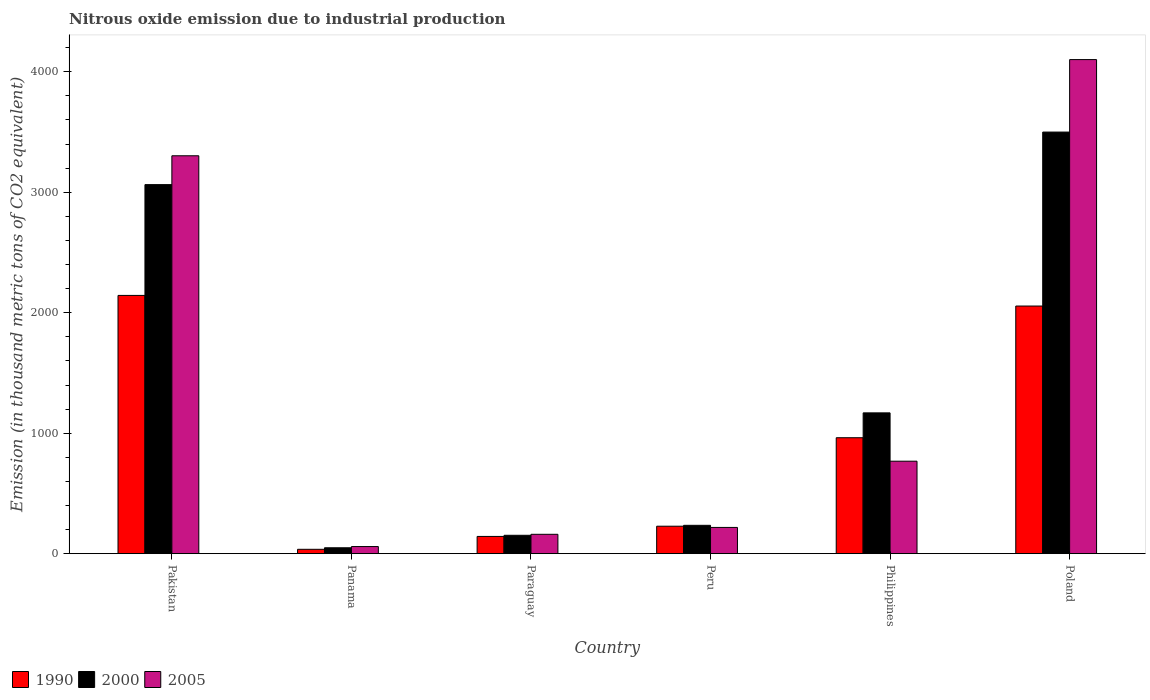How many different coloured bars are there?
Offer a terse response. 3. How many groups of bars are there?
Offer a very short reply. 6. Are the number of bars per tick equal to the number of legend labels?
Your answer should be compact. Yes. How many bars are there on the 6th tick from the left?
Your answer should be very brief. 3. How many bars are there on the 4th tick from the right?
Ensure brevity in your answer.  3. In how many cases, is the number of bars for a given country not equal to the number of legend labels?
Provide a short and direct response. 0. Across all countries, what is the maximum amount of nitrous oxide emitted in 2000?
Offer a terse response. 3499.7. Across all countries, what is the minimum amount of nitrous oxide emitted in 1990?
Provide a succinct answer. 36.2. In which country was the amount of nitrous oxide emitted in 1990 maximum?
Ensure brevity in your answer.  Pakistan. In which country was the amount of nitrous oxide emitted in 2000 minimum?
Ensure brevity in your answer.  Panama. What is the total amount of nitrous oxide emitted in 2000 in the graph?
Provide a short and direct response. 8168.4. What is the difference between the amount of nitrous oxide emitted in 2005 in Panama and that in Poland?
Your answer should be compact. -4042.5. What is the difference between the amount of nitrous oxide emitted in 2000 in Philippines and the amount of nitrous oxide emitted in 2005 in Paraguay?
Your answer should be very brief. 1008.1. What is the average amount of nitrous oxide emitted in 2000 per country?
Ensure brevity in your answer.  1361.4. What is the difference between the amount of nitrous oxide emitted of/in 2005 and amount of nitrous oxide emitted of/in 2000 in Poland?
Offer a very short reply. 601.8. What is the ratio of the amount of nitrous oxide emitted in 1990 in Pakistan to that in Paraguay?
Your answer should be compact. 14.99. Is the amount of nitrous oxide emitted in 1990 in Pakistan less than that in Philippines?
Give a very brief answer. No. Is the difference between the amount of nitrous oxide emitted in 2005 in Panama and Paraguay greater than the difference between the amount of nitrous oxide emitted in 2000 in Panama and Paraguay?
Offer a very short reply. Yes. What is the difference between the highest and the second highest amount of nitrous oxide emitted in 2005?
Provide a succinct answer. 798.6. What is the difference between the highest and the lowest amount of nitrous oxide emitted in 1990?
Provide a succinct answer. 2107.6. In how many countries, is the amount of nitrous oxide emitted in 2005 greater than the average amount of nitrous oxide emitted in 2005 taken over all countries?
Provide a short and direct response. 2. Is the sum of the amount of nitrous oxide emitted in 2005 in Peru and Philippines greater than the maximum amount of nitrous oxide emitted in 2000 across all countries?
Provide a short and direct response. No. What does the 3rd bar from the left in Philippines represents?
Your answer should be compact. 2005. Is it the case that in every country, the sum of the amount of nitrous oxide emitted in 2000 and amount of nitrous oxide emitted in 1990 is greater than the amount of nitrous oxide emitted in 2005?
Provide a short and direct response. Yes. How many bars are there?
Ensure brevity in your answer.  18. How many countries are there in the graph?
Make the answer very short. 6. What is the difference between two consecutive major ticks on the Y-axis?
Your answer should be compact. 1000. Where does the legend appear in the graph?
Your response must be concise. Bottom left. How are the legend labels stacked?
Give a very brief answer. Horizontal. What is the title of the graph?
Ensure brevity in your answer.  Nitrous oxide emission due to industrial production. What is the label or title of the X-axis?
Offer a terse response. Country. What is the label or title of the Y-axis?
Offer a very short reply. Emission (in thousand metric tons of CO2 equivalent). What is the Emission (in thousand metric tons of CO2 equivalent) in 1990 in Pakistan?
Provide a succinct answer. 2143.8. What is the Emission (in thousand metric tons of CO2 equivalent) of 2000 in Pakistan?
Your response must be concise. 3063.5. What is the Emission (in thousand metric tons of CO2 equivalent) in 2005 in Pakistan?
Your answer should be very brief. 3302.9. What is the Emission (in thousand metric tons of CO2 equivalent) of 1990 in Panama?
Provide a short and direct response. 36.2. What is the Emission (in thousand metric tons of CO2 equivalent) in 2000 in Panama?
Make the answer very short. 48.8. What is the Emission (in thousand metric tons of CO2 equivalent) in 2005 in Panama?
Your response must be concise. 59. What is the Emission (in thousand metric tons of CO2 equivalent) of 1990 in Paraguay?
Offer a very short reply. 143. What is the Emission (in thousand metric tons of CO2 equivalent) of 2000 in Paraguay?
Offer a terse response. 152.5. What is the Emission (in thousand metric tons of CO2 equivalent) in 2005 in Paraguay?
Offer a very short reply. 160.6. What is the Emission (in thousand metric tons of CO2 equivalent) in 1990 in Peru?
Keep it short and to the point. 227.9. What is the Emission (in thousand metric tons of CO2 equivalent) of 2000 in Peru?
Give a very brief answer. 235.2. What is the Emission (in thousand metric tons of CO2 equivalent) of 2005 in Peru?
Make the answer very short. 217.8. What is the Emission (in thousand metric tons of CO2 equivalent) of 1990 in Philippines?
Provide a short and direct response. 962.4. What is the Emission (in thousand metric tons of CO2 equivalent) in 2000 in Philippines?
Keep it short and to the point. 1168.7. What is the Emission (in thousand metric tons of CO2 equivalent) of 2005 in Philippines?
Keep it short and to the point. 767.6. What is the Emission (in thousand metric tons of CO2 equivalent) of 1990 in Poland?
Offer a terse response. 2055.6. What is the Emission (in thousand metric tons of CO2 equivalent) of 2000 in Poland?
Provide a short and direct response. 3499.7. What is the Emission (in thousand metric tons of CO2 equivalent) of 2005 in Poland?
Offer a terse response. 4101.5. Across all countries, what is the maximum Emission (in thousand metric tons of CO2 equivalent) of 1990?
Give a very brief answer. 2143.8. Across all countries, what is the maximum Emission (in thousand metric tons of CO2 equivalent) in 2000?
Ensure brevity in your answer.  3499.7. Across all countries, what is the maximum Emission (in thousand metric tons of CO2 equivalent) of 2005?
Offer a very short reply. 4101.5. Across all countries, what is the minimum Emission (in thousand metric tons of CO2 equivalent) of 1990?
Your response must be concise. 36.2. Across all countries, what is the minimum Emission (in thousand metric tons of CO2 equivalent) in 2000?
Offer a very short reply. 48.8. Across all countries, what is the minimum Emission (in thousand metric tons of CO2 equivalent) of 2005?
Offer a very short reply. 59. What is the total Emission (in thousand metric tons of CO2 equivalent) of 1990 in the graph?
Give a very brief answer. 5568.9. What is the total Emission (in thousand metric tons of CO2 equivalent) in 2000 in the graph?
Give a very brief answer. 8168.4. What is the total Emission (in thousand metric tons of CO2 equivalent) of 2005 in the graph?
Offer a terse response. 8609.4. What is the difference between the Emission (in thousand metric tons of CO2 equivalent) of 1990 in Pakistan and that in Panama?
Your answer should be compact. 2107.6. What is the difference between the Emission (in thousand metric tons of CO2 equivalent) of 2000 in Pakistan and that in Panama?
Offer a terse response. 3014.7. What is the difference between the Emission (in thousand metric tons of CO2 equivalent) in 2005 in Pakistan and that in Panama?
Your response must be concise. 3243.9. What is the difference between the Emission (in thousand metric tons of CO2 equivalent) in 1990 in Pakistan and that in Paraguay?
Your answer should be compact. 2000.8. What is the difference between the Emission (in thousand metric tons of CO2 equivalent) of 2000 in Pakistan and that in Paraguay?
Your answer should be compact. 2911. What is the difference between the Emission (in thousand metric tons of CO2 equivalent) of 2005 in Pakistan and that in Paraguay?
Provide a short and direct response. 3142.3. What is the difference between the Emission (in thousand metric tons of CO2 equivalent) of 1990 in Pakistan and that in Peru?
Your answer should be very brief. 1915.9. What is the difference between the Emission (in thousand metric tons of CO2 equivalent) in 2000 in Pakistan and that in Peru?
Provide a succinct answer. 2828.3. What is the difference between the Emission (in thousand metric tons of CO2 equivalent) of 2005 in Pakistan and that in Peru?
Your answer should be compact. 3085.1. What is the difference between the Emission (in thousand metric tons of CO2 equivalent) in 1990 in Pakistan and that in Philippines?
Offer a terse response. 1181.4. What is the difference between the Emission (in thousand metric tons of CO2 equivalent) of 2000 in Pakistan and that in Philippines?
Offer a very short reply. 1894.8. What is the difference between the Emission (in thousand metric tons of CO2 equivalent) in 2005 in Pakistan and that in Philippines?
Your answer should be compact. 2535.3. What is the difference between the Emission (in thousand metric tons of CO2 equivalent) of 1990 in Pakistan and that in Poland?
Your answer should be very brief. 88.2. What is the difference between the Emission (in thousand metric tons of CO2 equivalent) of 2000 in Pakistan and that in Poland?
Your answer should be compact. -436.2. What is the difference between the Emission (in thousand metric tons of CO2 equivalent) in 2005 in Pakistan and that in Poland?
Your response must be concise. -798.6. What is the difference between the Emission (in thousand metric tons of CO2 equivalent) in 1990 in Panama and that in Paraguay?
Make the answer very short. -106.8. What is the difference between the Emission (in thousand metric tons of CO2 equivalent) of 2000 in Panama and that in Paraguay?
Keep it short and to the point. -103.7. What is the difference between the Emission (in thousand metric tons of CO2 equivalent) of 2005 in Panama and that in Paraguay?
Ensure brevity in your answer.  -101.6. What is the difference between the Emission (in thousand metric tons of CO2 equivalent) of 1990 in Panama and that in Peru?
Give a very brief answer. -191.7. What is the difference between the Emission (in thousand metric tons of CO2 equivalent) in 2000 in Panama and that in Peru?
Keep it short and to the point. -186.4. What is the difference between the Emission (in thousand metric tons of CO2 equivalent) in 2005 in Panama and that in Peru?
Offer a terse response. -158.8. What is the difference between the Emission (in thousand metric tons of CO2 equivalent) of 1990 in Panama and that in Philippines?
Provide a succinct answer. -926.2. What is the difference between the Emission (in thousand metric tons of CO2 equivalent) of 2000 in Panama and that in Philippines?
Give a very brief answer. -1119.9. What is the difference between the Emission (in thousand metric tons of CO2 equivalent) of 2005 in Panama and that in Philippines?
Provide a short and direct response. -708.6. What is the difference between the Emission (in thousand metric tons of CO2 equivalent) of 1990 in Panama and that in Poland?
Your response must be concise. -2019.4. What is the difference between the Emission (in thousand metric tons of CO2 equivalent) of 2000 in Panama and that in Poland?
Your response must be concise. -3450.9. What is the difference between the Emission (in thousand metric tons of CO2 equivalent) in 2005 in Panama and that in Poland?
Make the answer very short. -4042.5. What is the difference between the Emission (in thousand metric tons of CO2 equivalent) in 1990 in Paraguay and that in Peru?
Provide a short and direct response. -84.9. What is the difference between the Emission (in thousand metric tons of CO2 equivalent) of 2000 in Paraguay and that in Peru?
Your response must be concise. -82.7. What is the difference between the Emission (in thousand metric tons of CO2 equivalent) of 2005 in Paraguay and that in Peru?
Ensure brevity in your answer.  -57.2. What is the difference between the Emission (in thousand metric tons of CO2 equivalent) in 1990 in Paraguay and that in Philippines?
Make the answer very short. -819.4. What is the difference between the Emission (in thousand metric tons of CO2 equivalent) of 2000 in Paraguay and that in Philippines?
Offer a terse response. -1016.2. What is the difference between the Emission (in thousand metric tons of CO2 equivalent) in 2005 in Paraguay and that in Philippines?
Your answer should be very brief. -607. What is the difference between the Emission (in thousand metric tons of CO2 equivalent) in 1990 in Paraguay and that in Poland?
Keep it short and to the point. -1912.6. What is the difference between the Emission (in thousand metric tons of CO2 equivalent) of 2000 in Paraguay and that in Poland?
Provide a short and direct response. -3347.2. What is the difference between the Emission (in thousand metric tons of CO2 equivalent) in 2005 in Paraguay and that in Poland?
Provide a short and direct response. -3940.9. What is the difference between the Emission (in thousand metric tons of CO2 equivalent) of 1990 in Peru and that in Philippines?
Provide a short and direct response. -734.5. What is the difference between the Emission (in thousand metric tons of CO2 equivalent) of 2000 in Peru and that in Philippines?
Give a very brief answer. -933.5. What is the difference between the Emission (in thousand metric tons of CO2 equivalent) of 2005 in Peru and that in Philippines?
Offer a very short reply. -549.8. What is the difference between the Emission (in thousand metric tons of CO2 equivalent) of 1990 in Peru and that in Poland?
Make the answer very short. -1827.7. What is the difference between the Emission (in thousand metric tons of CO2 equivalent) in 2000 in Peru and that in Poland?
Your answer should be compact. -3264.5. What is the difference between the Emission (in thousand metric tons of CO2 equivalent) of 2005 in Peru and that in Poland?
Provide a succinct answer. -3883.7. What is the difference between the Emission (in thousand metric tons of CO2 equivalent) of 1990 in Philippines and that in Poland?
Ensure brevity in your answer.  -1093.2. What is the difference between the Emission (in thousand metric tons of CO2 equivalent) in 2000 in Philippines and that in Poland?
Your answer should be very brief. -2331. What is the difference between the Emission (in thousand metric tons of CO2 equivalent) of 2005 in Philippines and that in Poland?
Give a very brief answer. -3333.9. What is the difference between the Emission (in thousand metric tons of CO2 equivalent) in 1990 in Pakistan and the Emission (in thousand metric tons of CO2 equivalent) in 2000 in Panama?
Provide a succinct answer. 2095. What is the difference between the Emission (in thousand metric tons of CO2 equivalent) of 1990 in Pakistan and the Emission (in thousand metric tons of CO2 equivalent) of 2005 in Panama?
Keep it short and to the point. 2084.8. What is the difference between the Emission (in thousand metric tons of CO2 equivalent) in 2000 in Pakistan and the Emission (in thousand metric tons of CO2 equivalent) in 2005 in Panama?
Your response must be concise. 3004.5. What is the difference between the Emission (in thousand metric tons of CO2 equivalent) of 1990 in Pakistan and the Emission (in thousand metric tons of CO2 equivalent) of 2000 in Paraguay?
Provide a succinct answer. 1991.3. What is the difference between the Emission (in thousand metric tons of CO2 equivalent) of 1990 in Pakistan and the Emission (in thousand metric tons of CO2 equivalent) of 2005 in Paraguay?
Give a very brief answer. 1983.2. What is the difference between the Emission (in thousand metric tons of CO2 equivalent) in 2000 in Pakistan and the Emission (in thousand metric tons of CO2 equivalent) in 2005 in Paraguay?
Offer a very short reply. 2902.9. What is the difference between the Emission (in thousand metric tons of CO2 equivalent) of 1990 in Pakistan and the Emission (in thousand metric tons of CO2 equivalent) of 2000 in Peru?
Your response must be concise. 1908.6. What is the difference between the Emission (in thousand metric tons of CO2 equivalent) of 1990 in Pakistan and the Emission (in thousand metric tons of CO2 equivalent) of 2005 in Peru?
Your response must be concise. 1926. What is the difference between the Emission (in thousand metric tons of CO2 equivalent) in 2000 in Pakistan and the Emission (in thousand metric tons of CO2 equivalent) in 2005 in Peru?
Keep it short and to the point. 2845.7. What is the difference between the Emission (in thousand metric tons of CO2 equivalent) in 1990 in Pakistan and the Emission (in thousand metric tons of CO2 equivalent) in 2000 in Philippines?
Make the answer very short. 975.1. What is the difference between the Emission (in thousand metric tons of CO2 equivalent) in 1990 in Pakistan and the Emission (in thousand metric tons of CO2 equivalent) in 2005 in Philippines?
Offer a very short reply. 1376.2. What is the difference between the Emission (in thousand metric tons of CO2 equivalent) of 2000 in Pakistan and the Emission (in thousand metric tons of CO2 equivalent) of 2005 in Philippines?
Make the answer very short. 2295.9. What is the difference between the Emission (in thousand metric tons of CO2 equivalent) in 1990 in Pakistan and the Emission (in thousand metric tons of CO2 equivalent) in 2000 in Poland?
Your response must be concise. -1355.9. What is the difference between the Emission (in thousand metric tons of CO2 equivalent) of 1990 in Pakistan and the Emission (in thousand metric tons of CO2 equivalent) of 2005 in Poland?
Your answer should be very brief. -1957.7. What is the difference between the Emission (in thousand metric tons of CO2 equivalent) of 2000 in Pakistan and the Emission (in thousand metric tons of CO2 equivalent) of 2005 in Poland?
Provide a succinct answer. -1038. What is the difference between the Emission (in thousand metric tons of CO2 equivalent) of 1990 in Panama and the Emission (in thousand metric tons of CO2 equivalent) of 2000 in Paraguay?
Your response must be concise. -116.3. What is the difference between the Emission (in thousand metric tons of CO2 equivalent) of 1990 in Panama and the Emission (in thousand metric tons of CO2 equivalent) of 2005 in Paraguay?
Offer a very short reply. -124.4. What is the difference between the Emission (in thousand metric tons of CO2 equivalent) in 2000 in Panama and the Emission (in thousand metric tons of CO2 equivalent) in 2005 in Paraguay?
Make the answer very short. -111.8. What is the difference between the Emission (in thousand metric tons of CO2 equivalent) of 1990 in Panama and the Emission (in thousand metric tons of CO2 equivalent) of 2000 in Peru?
Provide a short and direct response. -199. What is the difference between the Emission (in thousand metric tons of CO2 equivalent) of 1990 in Panama and the Emission (in thousand metric tons of CO2 equivalent) of 2005 in Peru?
Your response must be concise. -181.6. What is the difference between the Emission (in thousand metric tons of CO2 equivalent) of 2000 in Panama and the Emission (in thousand metric tons of CO2 equivalent) of 2005 in Peru?
Give a very brief answer. -169. What is the difference between the Emission (in thousand metric tons of CO2 equivalent) of 1990 in Panama and the Emission (in thousand metric tons of CO2 equivalent) of 2000 in Philippines?
Your answer should be compact. -1132.5. What is the difference between the Emission (in thousand metric tons of CO2 equivalent) in 1990 in Panama and the Emission (in thousand metric tons of CO2 equivalent) in 2005 in Philippines?
Your answer should be compact. -731.4. What is the difference between the Emission (in thousand metric tons of CO2 equivalent) of 2000 in Panama and the Emission (in thousand metric tons of CO2 equivalent) of 2005 in Philippines?
Ensure brevity in your answer.  -718.8. What is the difference between the Emission (in thousand metric tons of CO2 equivalent) in 1990 in Panama and the Emission (in thousand metric tons of CO2 equivalent) in 2000 in Poland?
Offer a very short reply. -3463.5. What is the difference between the Emission (in thousand metric tons of CO2 equivalent) of 1990 in Panama and the Emission (in thousand metric tons of CO2 equivalent) of 2005 in Poland?
Offer a very short reply. -4065.3. What is the difference between the Emission (in thousand metric tons of CO2 equivalent) of 2000 in Panama and the Emission (in thousand metric tons of CO2 equivalent) of 2005 in Poland?
Ensure brevity in your answer.  -4052.7. What is the difference between the Emission (in thousand metric tons of CO2 equivalent) in 1990 in Paraguay and the Emission (in thousand metric tons of CO2 equivalent) in 2000 in Peru?
Provide a succinct answer. -92.2. What is the difference between the Emission (in thousand metric tons of CO2 equivalent) in 1990 in Paraguay and the Emission (in thousand metric tons of CO2 equivalent) in 2005 in Peru?
Ensure brevity in your answer.  -74.8. What is the difference between the Emission (in thousand metric tons of CO2 equivalent) in 2000 in Paraguay and the Emission (in thousand metric tons of CO2 equivalent) in 2005 in Peru?
Give a very brief answer. -65.3. What is the difference between the Emission (in thousand metric tons of CO2 equivalent) in 1990 in Paraguay and the Emission (in thousand metric tons of CO2 equivalent) in 2000 in Philippines?
Offer a terse response. -1025.7. What is the difference between the Emission (in thousand metric tons of CO2 equivalent) in 1990 in Paraguay and the Emission (in thousand metric tons of CO2 equivalent) in 2005 in Philippines?
Give a very brief answer. -624.6. What is the difference between the Emission (in thousand metric tons of CO2 equivalent) of 2000 in Paraguay and the Emission (in thousand metric tons of CO2 equivalent) of 2005 in Philippines?
Provide a short and direct response. -615.1. What is the difference between the Emission (in thousand metric tons of CO2 equivalent) in 1990 in Paraguay and the Emission (in thousand metric tons of CO2 equivalent) in 2000 in Poland?
Provide a short and direct response. -3356.7. What is the difference between the Emission (in thousand metric tons of CO2 equivalent) in 1990 in Paraguay and the Emission (in thousand metric tons of CO2 equivalent) in 2005 in Poland?
Your answer should be compact. -3958.5. What is the difference between the Emission (in thousand metric tons of CO2 equivalent) of 2000 in Paraguay and the Emission (in thousand metric tons of CO2 equivalent) of 2005 in Poland?
Make the answer very short. -3949. What is the difference between the Emission (in thousand metric tons of CO2 equivalent) in 1990 in Peru and the Emission (in thousand metric tons of CO2 equivalent) in 2000 in Philippines?
Your answer should be compact. -940.8. What is the difference between the Emission (in thousand metric tons of CO2 equivalent) of 1990 in Peru and the Emission (in thousand metric tons of CO2 equivalent) of 2005 in Philippines?
Provide a short and direct response. -539.7. What is the difference between the Emission (in thousand metric tons of CO2 equivalent) of 2000 in Peru and the Emission (in thousand metric tons of CO2 equivalent) of 2005 in Philippines?
Provide a short and direct response. -532.4. What is the difference between the Emission (in thousand metric tons of CO2 equivalent) in 1990 in Peru and the Emission (in thousand metric tons of CO2 equivalent) in 2000 in Poland?
Make the answer very short. -3271.8. What is the difference between the Emission (in thousand metric tons of CO2 equivalent) of 1990 in Peru and the Emission (in thousand metric tons of CO2 equivalent) of 2005 in Poland?
Your response must be concise. -3873.6. What is the difference between the Emission (in thousand metric tons of CO2 equivalent) of 2000 in Peru and the Emission (in thousand metric tons of CO2 equivalent) of 2005 in Poland?
Offer a very short reply. -3866.3. What is the difference between the Emission (in thousand metric tons of CO2 equivalent) of 1990 in Philippines and the Emission (in thousand metric tons of CO2 equivalent) of 2000 in Poland?
Provide a succinct answer. -2537.3. What is the difference between the Emission (in thousand metric tons of CO2 equivalent) in 1990 in Philippines and the Emission (in thousand metric tons of CO2 equivalent) in 2005 in Poland?
Offer a terse response. -3139.1. What is the difference between the Emission (in thousand metric tons of CO2 equivalent) of 2000 in Philippines and the Emission (in thousand metric tons of CO2 equivalent) of 2005 in Poland?
Keep it short and to the point. -2932.8. What is the average Emission (in thousand metric tons of CO2 equivalent) of 1990 per country?
Your answer should be compact. 928.15. What is the average Emission (in thousand metric tons of CO2 equivalent) in 2000 per country?
Offer a terse response. 1361.4. What is the average Emission (in thousand metric tons of CO2 equivalent) of 2005 per country?
Your response must be concise. 1434.9. What is the difference between the Emission (in thousand metric tons of CO2 equivalent) in 1990 and Emission (in thousand metric tons of CO2 equivalent) in 2000 in Pakistan?
Your response must be concise. -919.7. What is the difference between the Emission (in thousand metric tons of CO2 equivalent) of 1990 and Emission (in thousand metric tons of CO2 equivalent) of 2005 in Pakistan?
Make the answer very short. -1159.1. What is the difference between the Emission (in thousand metric tons of CO2 equivalent) in 2000 and Emission (in thousand metric tons of CO2 equivalent) in 2005 in Pakistan?
Provide a succinct answer. -239.4. What is the difference between the Emission (in thousand metric tons of CO2 equivalent) of 1990 and Emission (in thousand metric tons of CO2 equivalent) of 2000 in Panama?
Ensure brevity in your answer.  -12.6. What is the difference between the Emission (in thousand metric tons of CO2 equivalent) in 1990 and Emission (in thousand metric tons of CO2 equivalent) in 2005 in Panama?
Your response must be concise. -22.8. What is the difference between the Emission (in thousand metric tons of CO2 equivalent) of 1990 and Emission (in thousand metric tons of CO2 equivalent) of 2000 in Paraguay?
Keep it short and to the point. -9.5. What is the difference between the Emission (in thousand metric tons of CO2 equivalent) of 1990 and Emission (in thousand metric tons of CO2 equivalent) of 2005 in Paraguay?
Make the answer very short. -17.6. What is the difference between the Emission (in thousand metric tons of CO2 equivalent) in 2000 and Emission (in thousand metric tons of CO2 equivalent) in 2005 in Paraguay?
Your answer should be compact. -8.1. What is the difference between the Emission (in thousand metric tons of CO2 equivalent) in 1990 and Emission (in thousand metric tons of CO2 equivalent) in 2005 in Peru?
Make the answer very short. 10.1. What is the difference between the Emission (in thousand metric tons of CO2 equivalent) in 1990 and Emission (in thousand metric tons of CO2 equivalent) in 2000 in Philippines?
Your response must be concise. -206.3. What is the difference between the Emission (in thousand metric tons of CO2 equivalent) in 1990 and Emission (in thousand metric tons of CO2 equivalent) in 2005 in Philippines?
Keep it short and to the point. 194.8. What is the difference between the Emission (in thousand metric tons of CO2 equivalent) of 2000 and Emission (in thousand metric tons of CO2 equivalent) of 2005 in Philippines?
Your response must be concise. 401.1. What is the difference between the Emission (in thousand metric tons of CO2 equivalent) in 1990 and Emission (in thousand metric tons of CO2 equivalent) in 2000 in Poland?
Provide a short and direct response. -1444.1. What is the difference between the Emission (in thousand metric tons of CO2 equivalent) of 1990 and Emission (in thousand metric tons of CO2 equivalent) of 2005 in Poland?
Give a very brief answer. -2045.9. What is the difference between the Emission (in thousand metric tons of CO2 equivalent) of 2000 and Emission (in thousand metric tons of CO2 equivalent) of 2005 in Poland?
Keep it short and to the point. -601.8. What is the ratio of the Emission (in thousand metric tons of CO2 equivalent) of 1990 in Pakistan to that in Panama?
Offer a terse response. 59.22. What is the ratio of the Emission (in thousand metric tons of CO2 equivalent) in 2000 in Pakistan to that in Panama?
Make the answer very short. 62.78. What is the ratio of the Emission (in thousand metric tons of CO2 equivalent) of 2005 in Pakistan to that in Panama?
Keep it short and to the point. 55.98. What is the ratio of the Emission (in thousand metric tons of CO2 equivalent) of 1990 in Pakistan to that in Paraguay?
Your answer should be compact. 14.99. What is the ratio of the Emission (in thousand metric tons of CO2 equivalent) in 2000 in Pakistan to that in Paraguay?
Make the answer very short. 20.09. What is the ratio of the Emission (in thousand metric tons of CO2 equivalent) of 2005 in Pakistan to that in Paraguay?
Your answer should be very brief. 20.57. What is the ratio of the Emission (in thousand metric tons of CO2 equivalent) in 1990 in Pakistan to that in Peru?
Give a very brief answer. 9.41. What is the ratio of the Emission (in thousand metric tons of CO2 equivalent) in 2000 in Pakistan to that in Peru?
Provide a succinct answer. 13.03. What is the ratio of the Emission (in thousand metric tons of CO2 equivalent) of 2005 in Pakistan to that in Peru?
Provide a short and direct response. 15.16. What is the ratio of the Emission (in thousand metric tons of CO2 equivalent) in 1990 in Pakistan to that in Philippines?
Make the answer very short. 2.23. What is the ratio of the Emission (in thousand metric tons of CO2 equivalent) in 2000 in Pakistan to that in Philippines?
Provide a short and direct response. 2.62. What is the ratio of the Emission (in thousand metric tons of CO2 equivalent) of 2005 in Pakistan to that in Philippines?
Your response must be concise. 4.3. What is the ratio of the Emission (in thousand metric tons of CO2 equivalent) of 1990 in Pakistan to that in Poland?
Ensure brevity in your answer.  1.04. What is the ratio of the Emission (in thousand metric tons of CO2 equivalent) in 2000 in Pakistan to that in Poland?
Ensure brevity in your answer.  0.88. What is the ratio of the Emission (in thousand metric tons of CO2 equivalent) in 2005 in Pakistan to that in Poland?
Your answer should be very brief. 0.81. What is the ratio of the Emission (in thousand metric tons of CO2 equivalent) in 1990 in Panama to that in Paraguay?
Your response must be concise. 0.25. What is the ratio of the Emission (in thousand metric tons of CO2 equivalent) of 2000 in Panama to that in Paraguay?
Keep it short and to the point. 0.32. What is the ratio of the Emission (in thousand metric tons of CO2 equivalent) in 2005 in Panama to that in Paraguay?
Make the answer very short. 0.37. What is the ratio of the Emission (in thousand metric tons of CO2 equivalent) of 1990 in Panama to that in Peru?
Provide a short and direct response. 0.16. What is the ratio of the Emission (in thousand metric tons of CO2 equivalent) of 2000 in Panama to that in Peru?
Offer a terse response. 0.21. What is the ratio of the Emission (in thousand metric tons of CO2 equivalent) in 2005 in Panama to that in Peru?
Your answer should be very brief. 0.27. What is the ratio of the Emission (in thousand metric tons of CO2 equivalent) of 1990 in Panama to that in Philippines?
Provide a succinct answer. 0.04. What is the ratio of the Emission (in thousand metric tons of CO2 equivalent) in 2000 in Panama to that in Philippines?
Provide a short and direct response. 0.04. What is the ratio of the Emission (in thousand metric tons of CO2 equivalent) in 2005 in Panama to that in Philippines?
Your response must be concise. 0.08. What is the ratio of the Emission (in thousand metric tons of CO2 equivalent) of 1990 in Panama to that in Poland?
Provide a succinct answer. 0.02. What is the ratio of the Emission (in thousand metric tons of CO2 equivalent) of 2000 in Panama to that in Poland?
Make the answer very short. 0.01. What is the ratio of the Emission (in thousand metric tons of CO2 equivalent) of 2005 in Panama to that in Poland?
Ensure brevity in your answer.  0.01. What is the ratio of the Emission (in thousand metric tons of CO2 equivalent) in 1990 in Paraguay to that in Peru?
Keep it short and to the point. 0.63. What is the ratio of the Emission (in thousand metric tons of CO2 equivalent) of 2000 in Paraguay to that in Peru?
Provide a short and direct response. 0.65. What is the ratio of the Emission (in thousand metric tons of CO2 equivalent) in 2005 in Paraguay to that in Peru?
Your response must be concise. 0.74. What is the ratio of the Emission (in thousand metric tons of CO2 equivalent) in 1990 in Paraguay to that in Philippines?
Make the answer very short. 0.15. What is the ratio of the Emission (in thousand metric tons of CO2 equivalent) in 2000 in Paraguay to that in Philippines?
Offer a terse response. 0.13. What is the ratio of the Emission (in thousand metric tons of CO2 equivalent) of 2005 in Paraguay to that in Philippines?
Your answer should be compact. 0.21. What is the ratio of the Emission (in thousand metric tons of CO2 equivalent) of 1990 in Paraguay to that in Poland?
Provide a succinct answer. 0.07. What is the ratio of the Emission (in thousand metric tons of CO2 equivalent) of 2000 in Paraguay to that in Poland?
Offer a terse response. 0.04. What is the ratio of the Emission (in thousand metric tons of CO2 equivalent) in 2005 in Paraguay to that in Poland?
Offer a very short reply. 0.04. What is the ratio of the Emission (in thousand metric tons of CO2 equivalent) in 1990 in Peru to that in Philippines?
Your answer should be very brief. 0.24. What is the ratio of the Emission (in thousand metric tons of CO2 equivalent) of 2000 in Peru to that in Philippines?
Provide a short and direct response. 0.2. What is the ratio of the Emission (in thousand metric tons of CO2 equivalent) in 2005 in Peru to that in Philippines?
Ensure brevity in your answer.  0.28. What is the ratio of the Emission (in thousand metric tons of CO2 equivalent) of 1990 in Peru to that in Poland?
Offer a very short reply. 0.11. What is the ratio of the Emission (in thousand metric tons of CO2 equivalent) in 2000 in Peru to that in Poland?
Provide a short and direct response. 0.07. What is the ratio of the Emission (in thousand metric tons of CO2 equivalent) in 2005 in Peru to that in Poland?
Provide a succinct answer. 0.05. What is the ratio of the Emission (in thousand metric tons of CO2 equivalent) in 1990 in Philippines to that in Poland?
Your answer should be very brief. 0.47. What is the ratio of the Emission (in thousand metric tons of CO2 equivalent) of 2000 in Philippines to that in Poland?
Keep it short and to the point. 0.33. What is the ratio of the Emission (in thousand metric tons of CO2 equivalent) in 2005 in Philippines to that in Poland?
Provide a short and direct response. 0.19. What is the difference between the highest and the second highest Emission (in thousand metric tons of CO2 equivalent) of 1990?
Make the answer very short. 88.2. What is the difference between the highest and the second highest Emission (in thousand metric tons of CO2 equivalent) in 2000?
Make the answer very short. 436.2. What is the difference between the highest and the second highest Emission (in thousand metric tons of CO2 equivalent) in 2005?
Offer a terse response. 798.6. What is the difference between the highest and the lowest Emission (in thousand metric tons of CO2 equivalent) in 1990?
Provide a short and direct response. 2107.6. What is the difference between the highest and the lowest Emission (in thousand metric tons of CO2 equivalent) in 2000?
Your response must be concise. 3450.9. What is the difference between the highest and the lowest Emission (in thousand metric tons of CO2 equivalent) in 2005?
Your answer should be compact. 4042.5. 